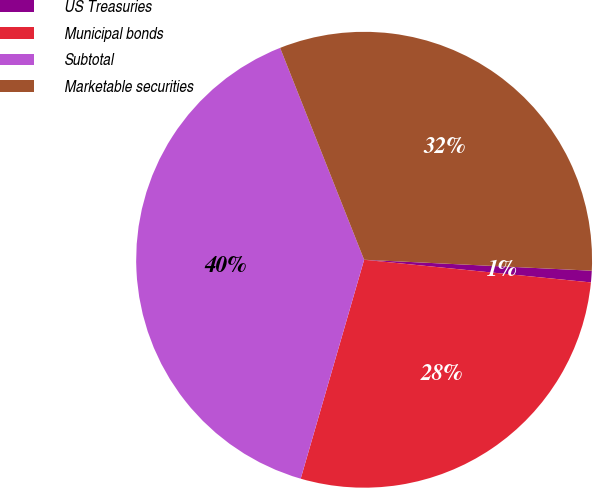Convert chart to OTSL. <chart><loc_0><loc_0><loc_500><loc_500><pie_chart><fcel>US Treasuries<fcel>Municipal bonds<fcel>Subtotal<fcel>Marketable securities<nl><fcel>0.82%<fcel>27.9%<fcel>39.5%<fcel>31.77%<nl></chart> 